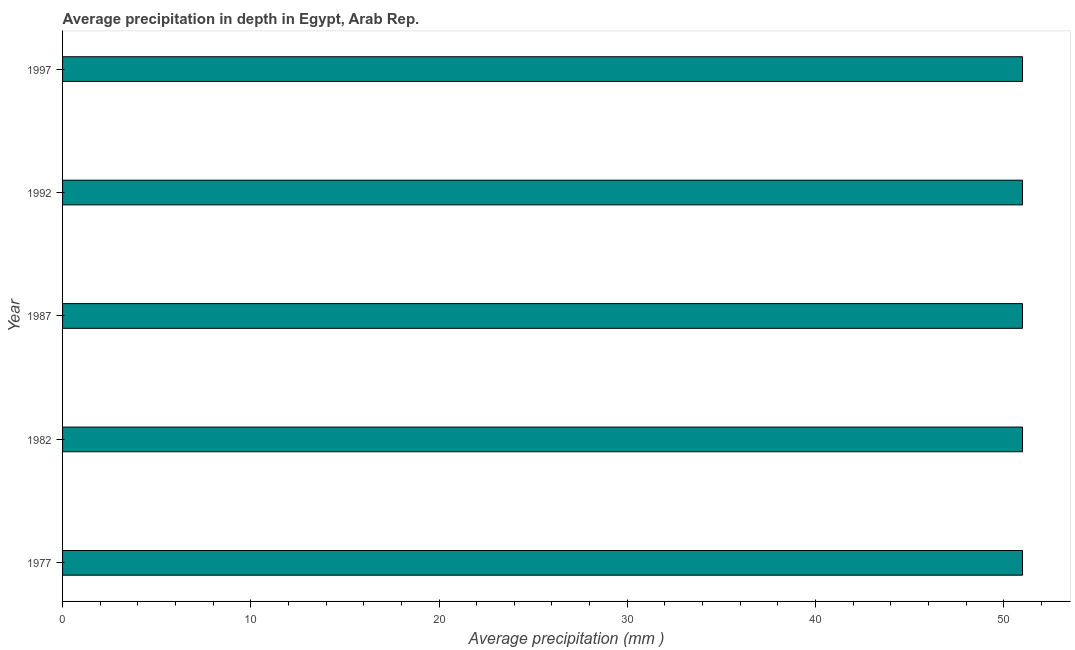What is the title of the graph?
Offer a terse response. Average precipitation in depth in Egypt, Arab Rep. What is the label or title of the X-axis?
Provide a short and direct response. Average precipitation (mm ). What is the label or title of the Y-axis?
Provide a short and direct response. Year. Across all years, what is the maximum average precipitation in depth?
Provide a succinct answer. 51. Across all years, what is the minimum average precipitation in depth?
Offer a very short reply. 51. In which year was the average precipitation in depth maximum?
Your response must be concise. 1977. In which year was the average precipitation in depth minimum?
Keep it short and to the point. 1977. What is the sum of the average precipitation in depth?
Offer a very short reply. 255. What is the difference between the average precipitation in depth in 1977 and 1987?
Keep it short and to the point. 0. What is the median average precipitation in depth?
Make the answer very short. 51. Do a majority of the years between 1982 and 1997 (inclusive) have average precipitation in depth greater than 10 mm?
Your answer should be very brief. Yes. What is the difference between the highest and the second highest average precipitation in depth?
Your answer should be very brief. 0. In how many years, is the average precipitation in depth greater than the average average precipitation in depth taken over all years?
Your answer should be compact. 0. How many bars are there?
Give a very brief answer. 5. Are all the bars in the graph horizontal?
Keep it short and to the point. Yes. What is the difference between two consecutive major ticks on the X-axis?
Give a very brief answer. 10. Are the values on the major ticks of X-axis written in scientific E-notation?
Give a very brief answer. No. What is the Average precipitation (mm ) in 1977?
Provide a succinct answer. 51. What is the Average precipitation (mm ) of 1987?
Your response must be concise. 51. What is the Average precipitation (mm ) of 1992?
Offer a very short reply. 51. What is the difference between the Average precipitation (mm ) in 1977 and 1982?
Your answer should be compact. 0. What is the difference between the Average precipitation (mm ) in 1982 and 1997?
Ensure brevity in your answer.  0. What is the difference between the Average precipitation (mm ) in 1987 and 1992?
Your answer should be very brief. 0. What is the difference between the Average precipitation (mm ) in 1992 and 1997?
Make the answer very short. 0. What is the ratio of the Average precipitation (mm ) in 1977 to that in 1982?
Offer a very short reply. 1. What is the ratio of the Average precipitation (mm ) in 1977 to that in 1987?
Your response must be concise. 1. What is the ratio of the Average precipitation (mm ) in 1982 to that in 1992?
Your answer should be very brief. 1. What is the ratio of the Average precipitation (mm ) in 1987 to that in 1992?
Your response must be concise. 1. What is the ratio of the Average precipitation (mm ) in 1987 to that in 1997?
Your answer should be compact. 1. 